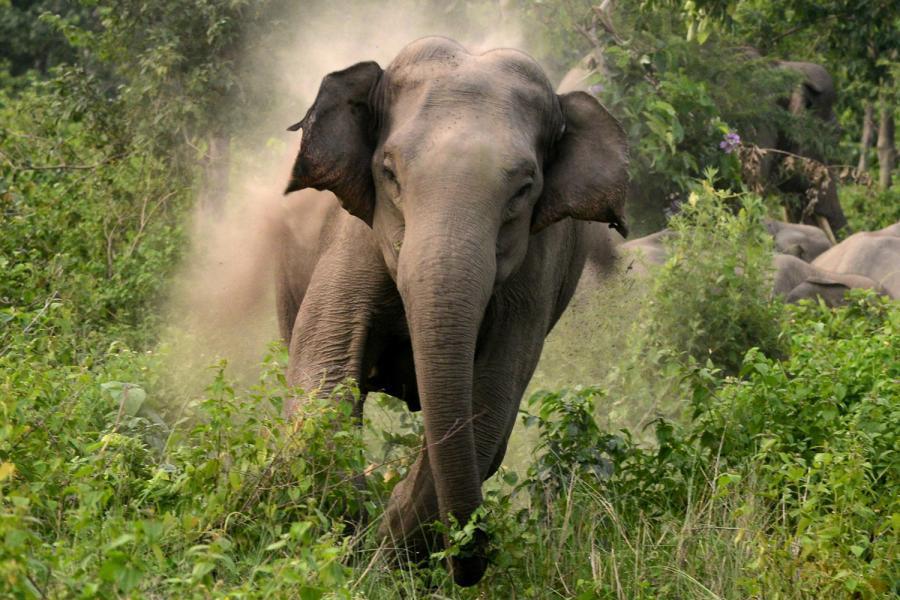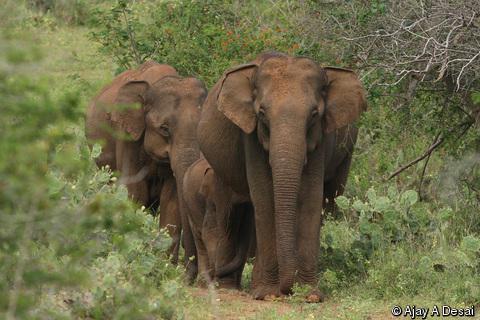The first image is the image on the left, the second image is the image on the right. Evaluate the accuracy of this statement regarding the images: "An image shows an elephant with tusks facing the camera.". Is it true? Answer yes or no. No. The first image is the image on the left, the second image is the image on the right. Examine the images to the left and right. Is the description "Two elephants, an adult and a baby, are walking through a grassy field." accurate? Answer yes or no. No. 